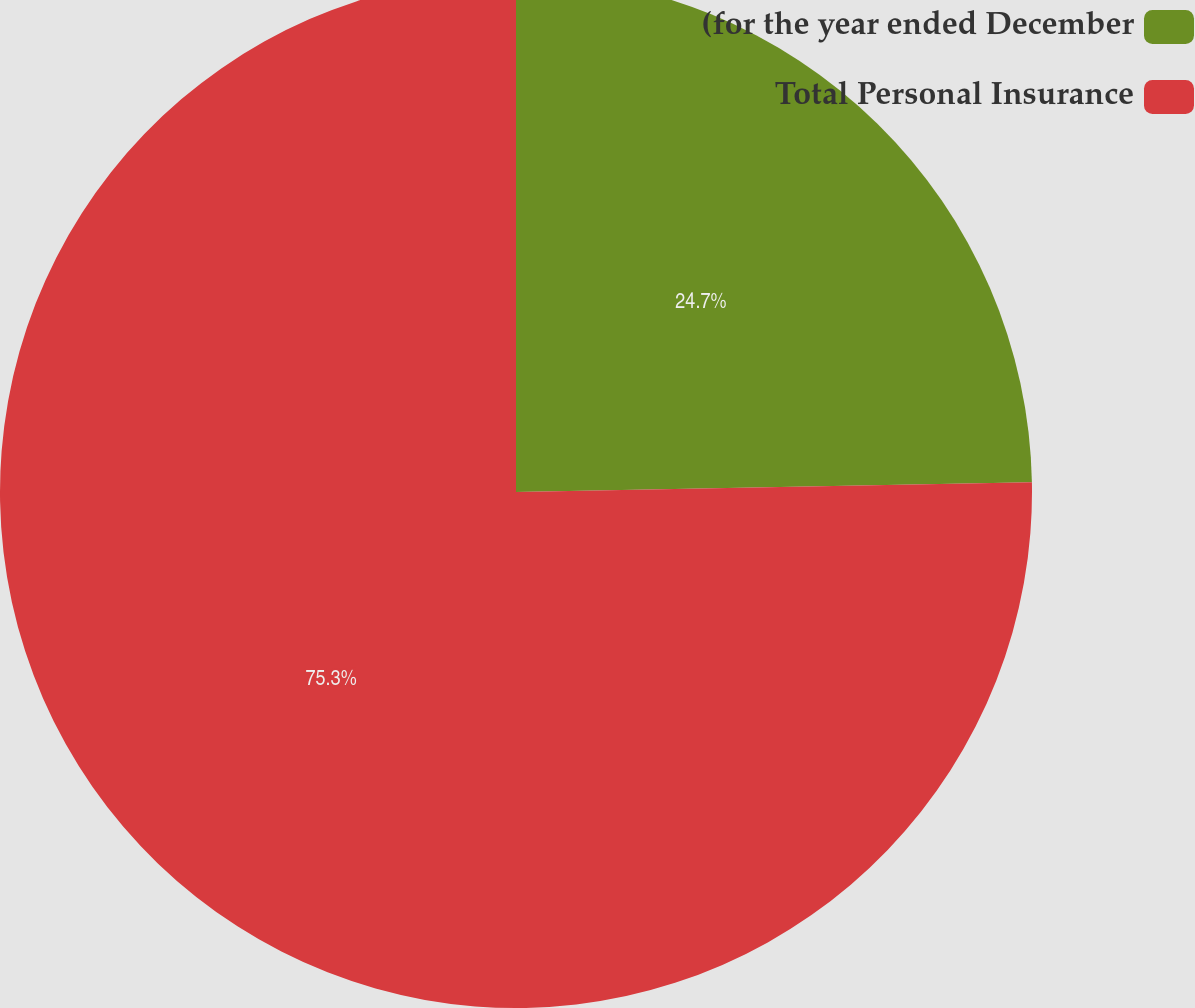Convert chart to OTSL. <chart><loc_0><loc_0><loc_500><loc_500><pie_chart><fcel>(for the year ended December<fcel>Total Personal Insurance<nl><fcel>24.7%<fcel>75.3%<nl></chart> 